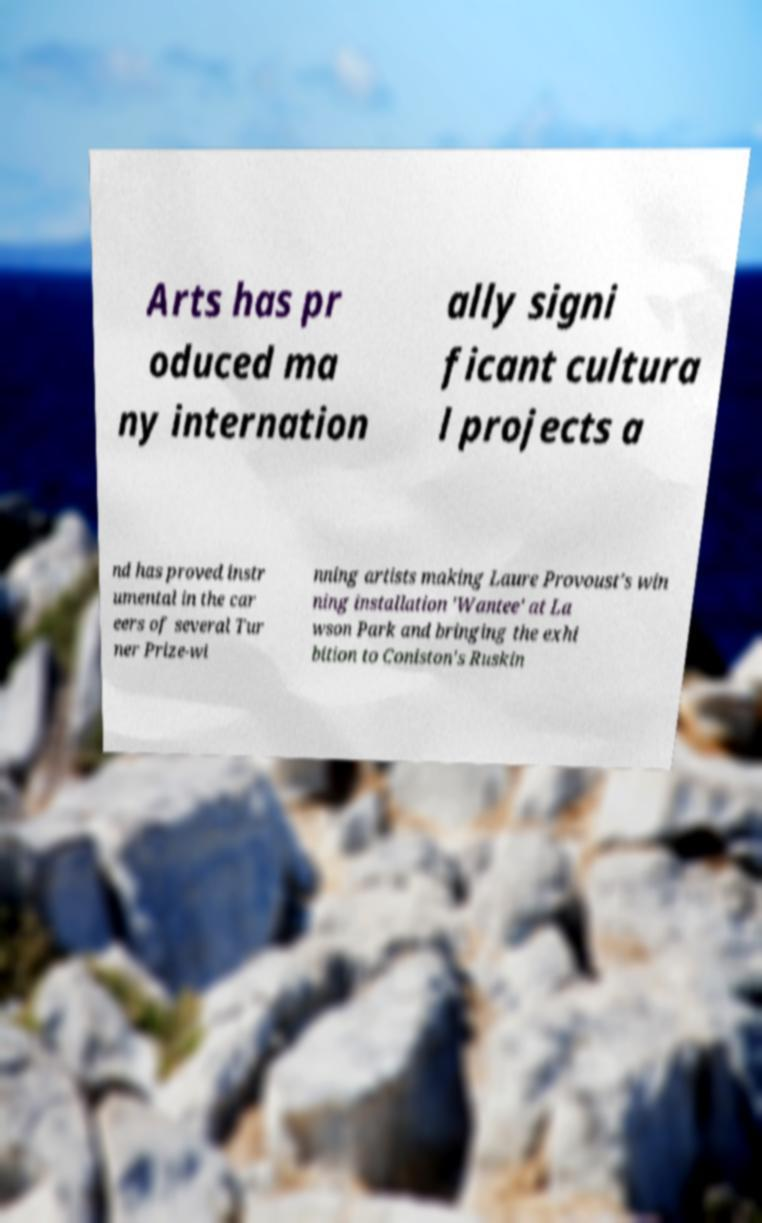Can you accurately transcribe the text from the provided image for me? Arts has pr oduced ma ny internation ally signi ficant cultura l projects a nd has proved instr umental in the car eers of several Tur ner Prize-wi nning artists making Laure Provoust's win ning installation 'Wantee' at La wson Park and bringing the exhi bition to Coniston's Ruskin 